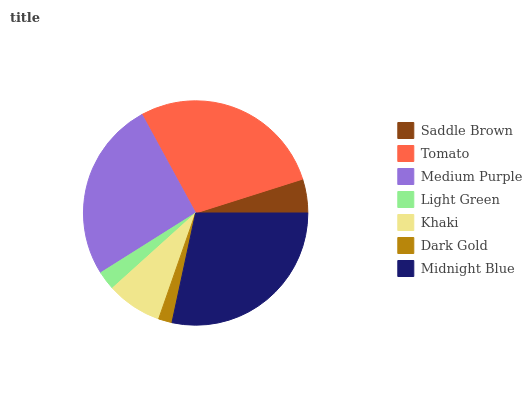Is Dark Gold the minimum?
Answer yes or no. Yes. Is Midnight Blue the maximum?
Answer yes or no. Yes. Is Tomato the minimum?
Answer yes or no. No. Is Tomato the maximum?
Answer yes or no. No. Is Tomato greater than Saddle Brown?
Answer yes or no. Yes. Is Saddle Brown less than Tomato?
Answer yes or no. Yes. Is Saddle Brown greater than Tomato?
Answer yes or no. No. Is Tomato less than Saddle Brown?
Answer yes or no. No. Is Khaki the high median?
Answer yes or no. Yes. Is Khaki the low median?
Answer yes or no. Yes. Is Saddle Brown the high median?
Answer yes or no. No. Is Medium Purple the low median?
Answer yes or no. No. 